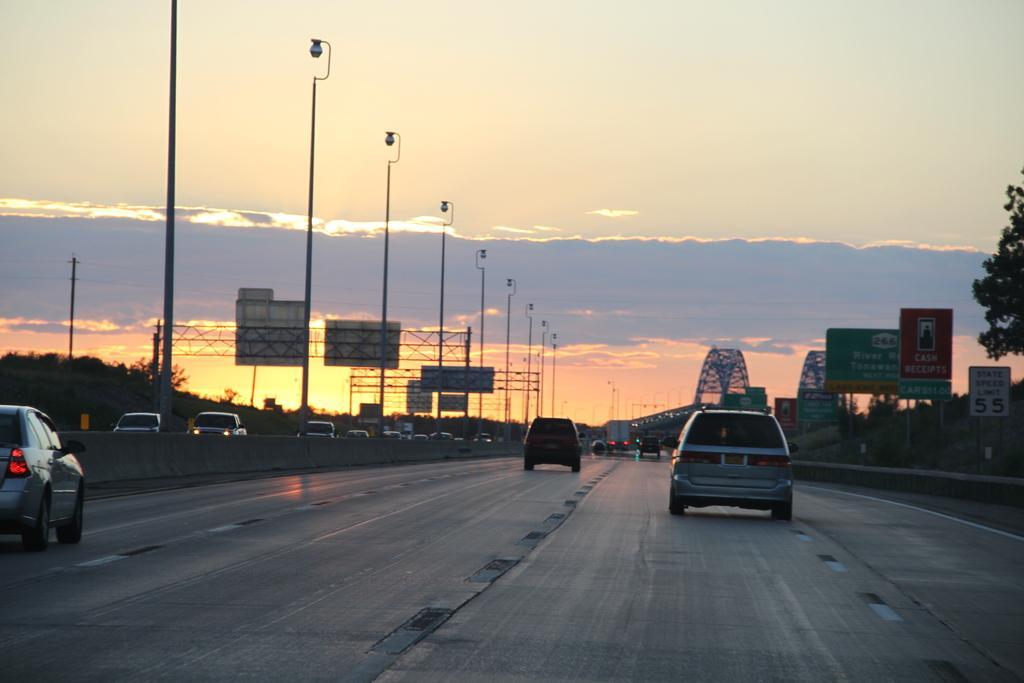Could you give a brief overview of what you see in this image? In this picture I can see few vehicles are moving on the road, on the right side there are boards and trees. At the top there is the sky. 